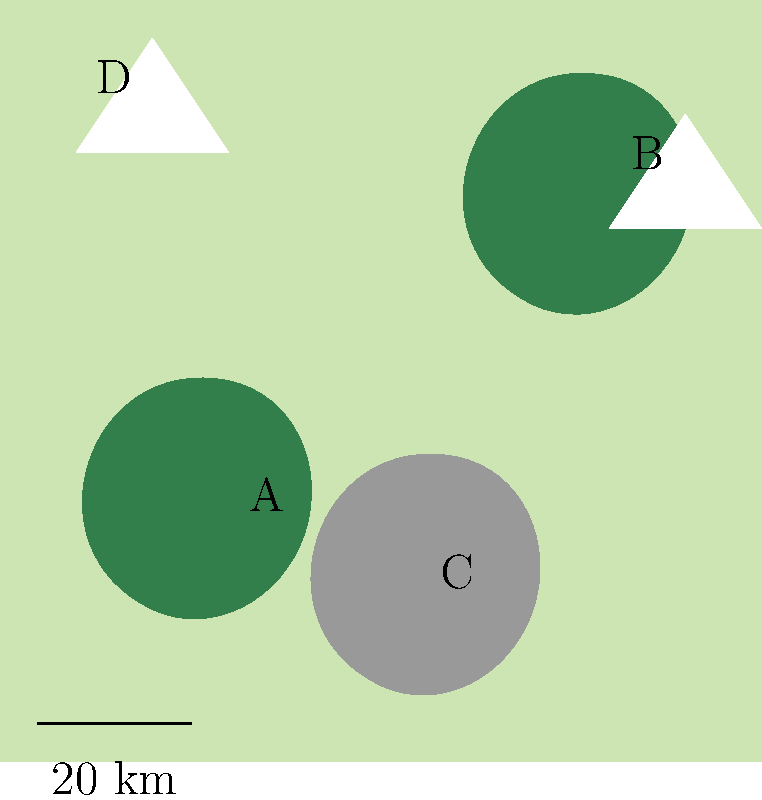Based on the satellite imagery of a potential snow leopard habitat range, which area is most likely to support the highest density of snow leopards? Consider factors such as terrain, vegetation, and proximity to prey habitats. To determine the area most likely to support the highest density of snow leopards, we need to consider several factors:

1. Terrain: Snow leopards prefer rugged, mountainous terrain with steep slopes and rocky areas.
2. Vegetation: They inhabit areas with sparse vegetation, typically above the tree line.
3. Proximity to prey habitats: Snow leopards need access to areas where their prey (such as mountain goats and sheep) can graze.

Let's analyze each area:

A) This area appears to be forested, which is not ideal for snow leopards as they prefer more open, high-altitude habitats.

B) This region includes a snow-capped peak and is close to a forested area. It could potentially support snow leopards, but might not be the optimal choice.

C) This area is rocky and at a lower elevation. While it might provide some suitable terrain, it lacks the high-altitude characteristics preferred by snow leopards.

D) This area includes a snow-capped peak and is adjacent to what appears to be alpine grassland. It offers the following advantages:
   - High-altitude terrain (snow-capped peak)
   - Proximity to potential grazing areas for prey (adjacent grassland)
   - Likely rocky terrain near the peak, providing cover and den sites
   - Above the tree line, matching the preferred habitat of snow leopards

The combination of these factors makes area D the most likely to support the highest density of snow leopards among the given options.
Answer: Area D 